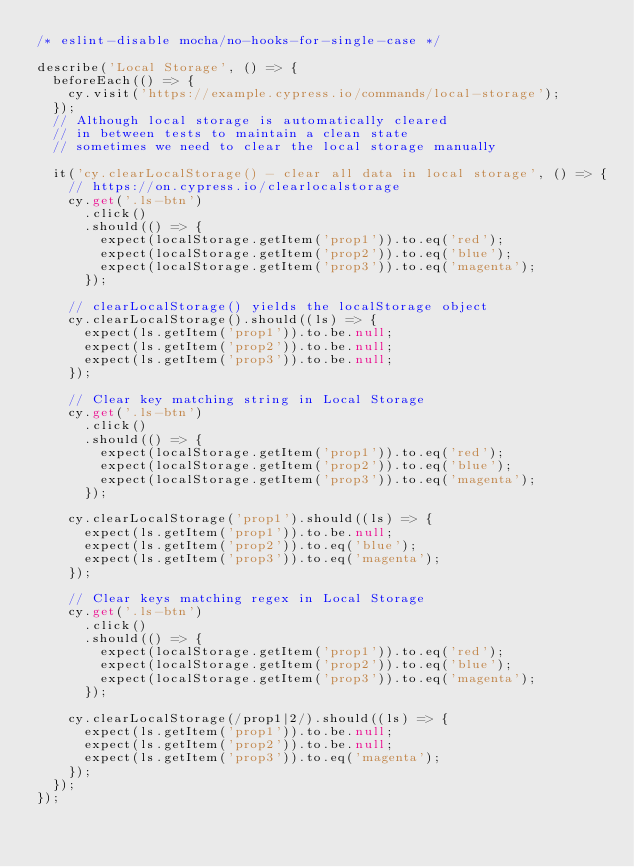Convert code to text. <code><loc_0><loc_0><loc_500><loc_500><_TypeScript_>/* eslint-disable mocha/no-hooks-for-single-case */

describe('Local Storage', () => {
  beforeEach(() => {
    cy.visit('https://example.cypress.io/commands/local-storage');
  });
  // Although local storage is automatically cleared
  // in between tests to maintain a clean state
  // sometimes we need to clear the local storage manually

  it('cy.clearLocalStorage() - clear all data in local storage', () => {
    // https://on.cypress.io/clearlocalstorage
    cy.get('.ls-btn')
      .click()
      .should(() => {
        expect(localStorage.getItem('prop1')).to.eq('red');
        expect(localStorage.getItem('prop2')).to.eq('blue');
        expect(localStorage.getItem('prop3')).to.eq('magenta');
      });

    // clearLocalStorage() yields the localStorage object
    cy.clearLocalStorage().should((ls) => {
      expect(ls.getItem('prop1')).to.be.null;
      expect(ls.getItem('prop2')).to.be.null;
      expect(ls.getItem('prop3')).to.be.null;
    });

    // Clear key matching string in Local Storage
    cy.get('.ls-btn')
      .click()
      .should(() => {
        expect(localStorage.getItem('prop1')).to.eq('red');
        expect(localStorage.getItem('prop2')).to.eq('blue');
        expect(localStorage.getItem('prop3')).to.eq('magenta');
      });

    cy.clearLocalStorage('prop1').should((ls) => {
      expect(ls.getItem('prop1')).to.be.null;
      expect(ls.getItem('prop2')).to.eq('blue');
      expect(ls.getItem('prop3')).to.eq('magenta');
    });

    // Clear keys matching regex in Local Storage
    cy.get('.ls-btn')
      .click()
      .should(() => {
        expect(localStorage.getItem('prop1')).to.eq('red');
        expect(localStorage.getItem('prop2')).to.eq('blue');
        expect(localStorage.getItem('prop3')).to.eq('magenta');
      });

    cy.clearLocalStorage(/prop1|2/).should((ls) => {
      expect(ls.getItem('prop1')).to.be.null;
      expect(ls.getItem('prop2')).to.be.null;
      expect(ls.getItem('prop3')).to.eq('magenta');
    });
  });
});
</code> 